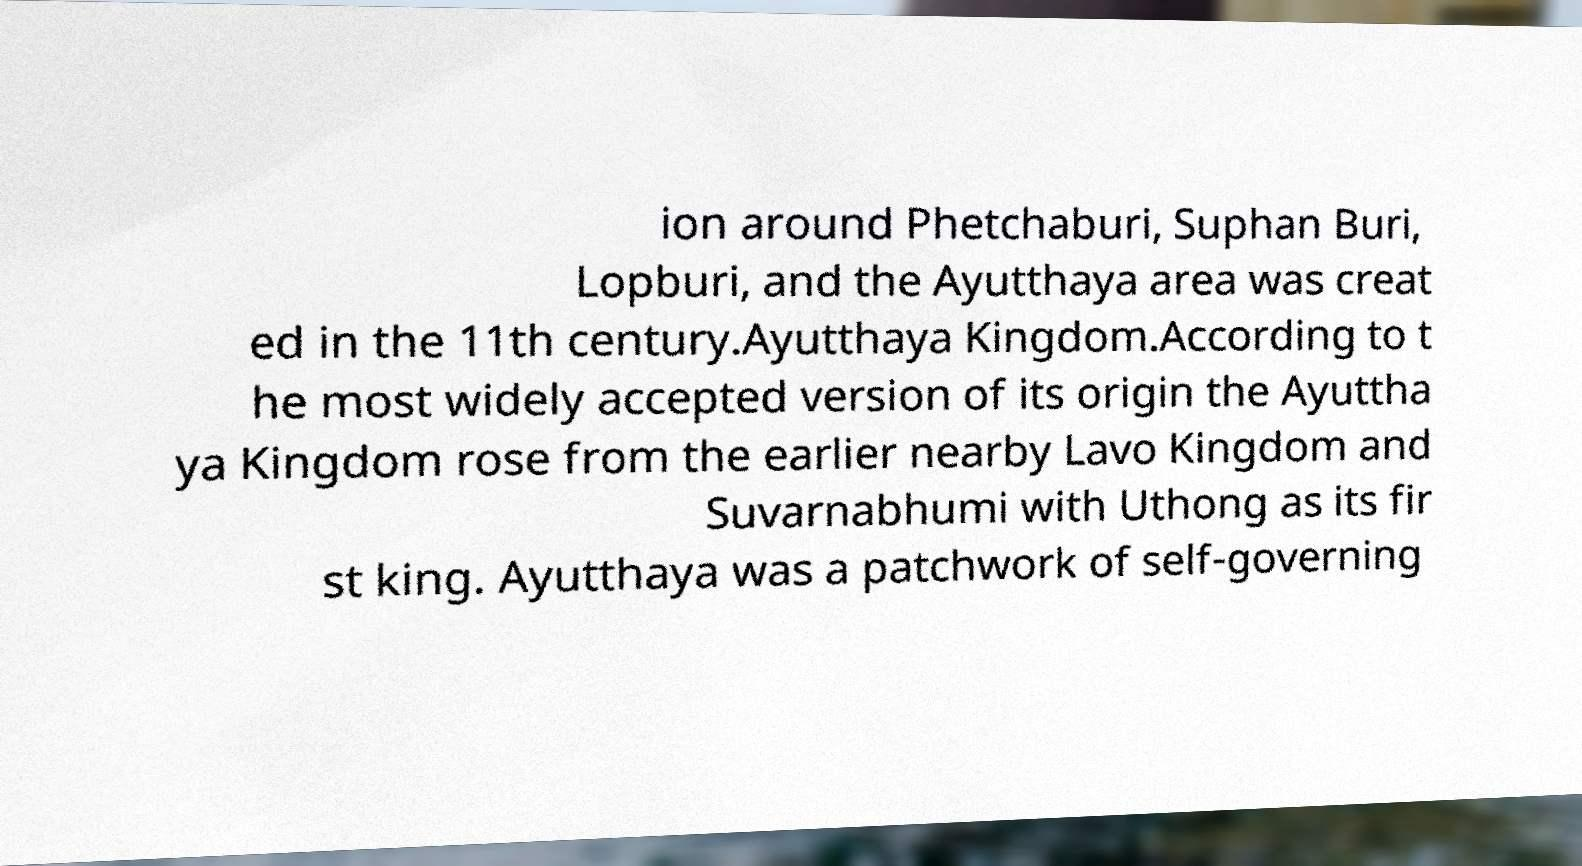Could you assist in decoding the text presented in this image and type it out clearly? ion around Phetchaburi, Suphan Buri, Lopburi, and the Ayutthaya area was creat ed in the 11th century.Ayutthaya Kingdom.According to t he most widely accepted version of its origin the Ayuttha ya Kingdom rose from the earlier nearby Lavo Kingdom and Suvarnabhumi with Uthong as its fir st king. Ayutthaya was a patchwork of self-governing 